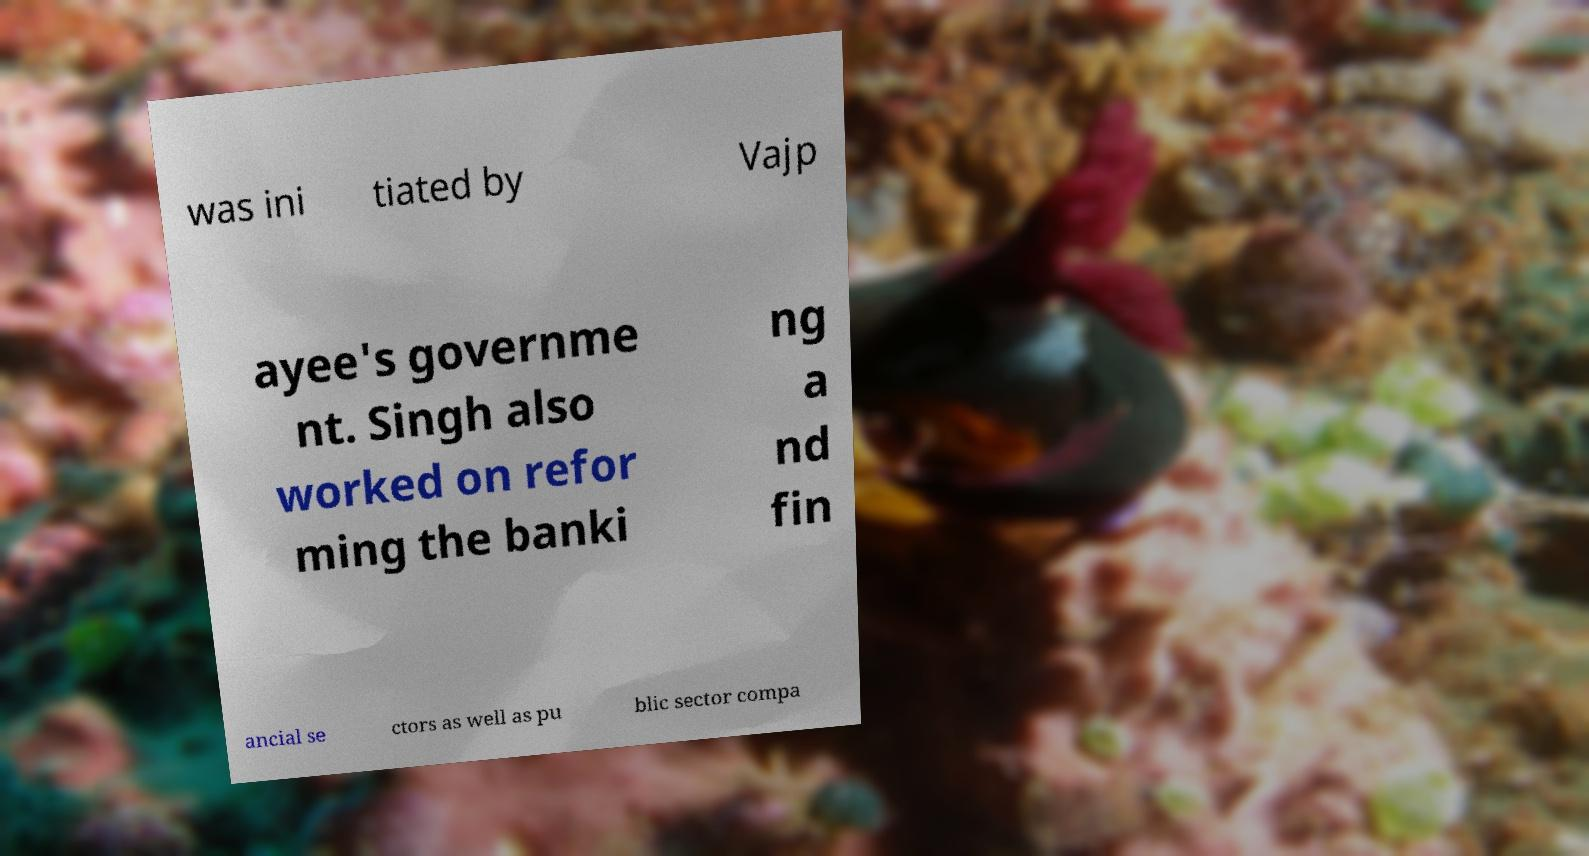Please identify and transcribe the text found in this image. was ini tiated by Vajp ayee's governme nt. Singh also worked on refor ming the banki ng a nd fin ancial se ctors as well as pu blic sector compa 